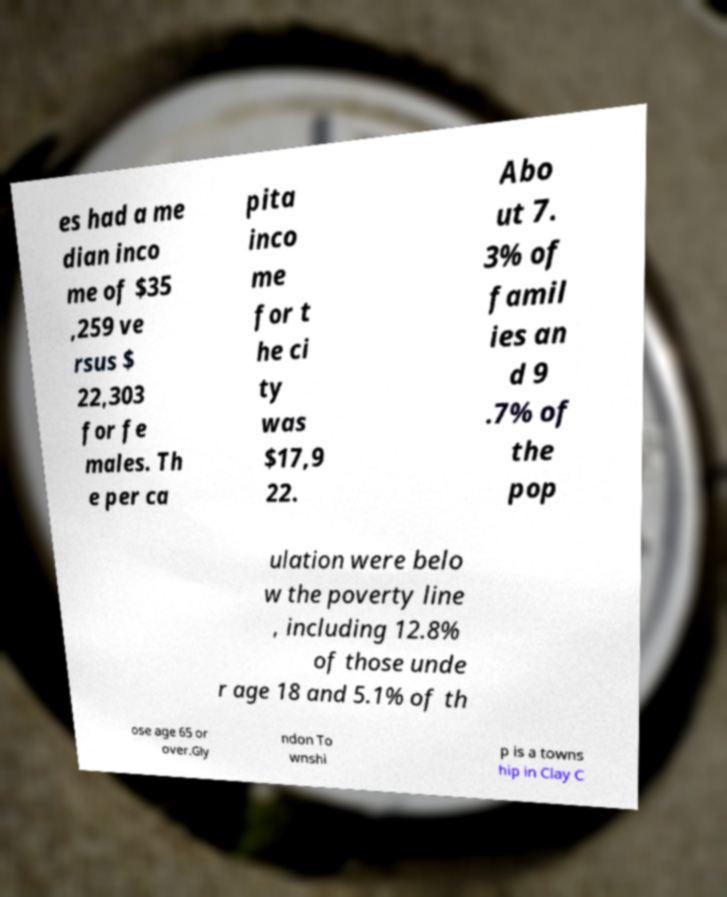Can you read and provide the text displayed in the image?This photo seems to have some interesting text. Can you extract and type it out for me? es had a me dian inco me of $35 ,259 ve rsus $ 22,303 for fe males. Th e per ca pita inco me for t he ci ty was $17,9 22. Abo ut 7. 3% of famil ies an d 9 .7% of the pop ulation were belo w the poverty line , including 12.8% of those unde r age 18 and 5.1% of th ose age 65 or over.Gly ndon To wnshi p is a towns hip in Clay C 